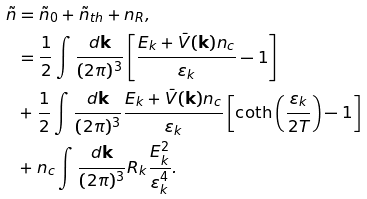<formula> <loc_0><loc_0><loc_500><loc_500>\tilde { n } & = \tilde { n } _ { 0 } + \tilde { n } _ { t h } + n _ { R } , \\ & = \frac { 1 } { 2 } \int \frac { d \mathbf k } { ( 2 \pi ) ^ { 3 } } \left [ \frac { E _ { k } + \bar { V } ( \mathbf k ) n _ { c } } { \varepsilon _ { k } } - 1 \right ] \\ & + \frac { 1 } { 2 } \int \frac { d \mathbf k } { ( 2 \pi ) ^ { 3 } } \frac { E _ { k } + \bar { V } ( \mathbf k ) n _ { c } } { \varepsilon _ { k } } \left [ \coth \left ( \frac { \varepsilon _ { k } } { 2 T } \right ) - 1 \right ] \\ & + n _ { c } \int \frac { d \mathbf k } { ( 2 \pi ) ^ { 3 } } R _ { k } \frac { E _ { k } ^ { 2 } } { \varepsilon _ { k } ^ { 4 } } .</formula> 